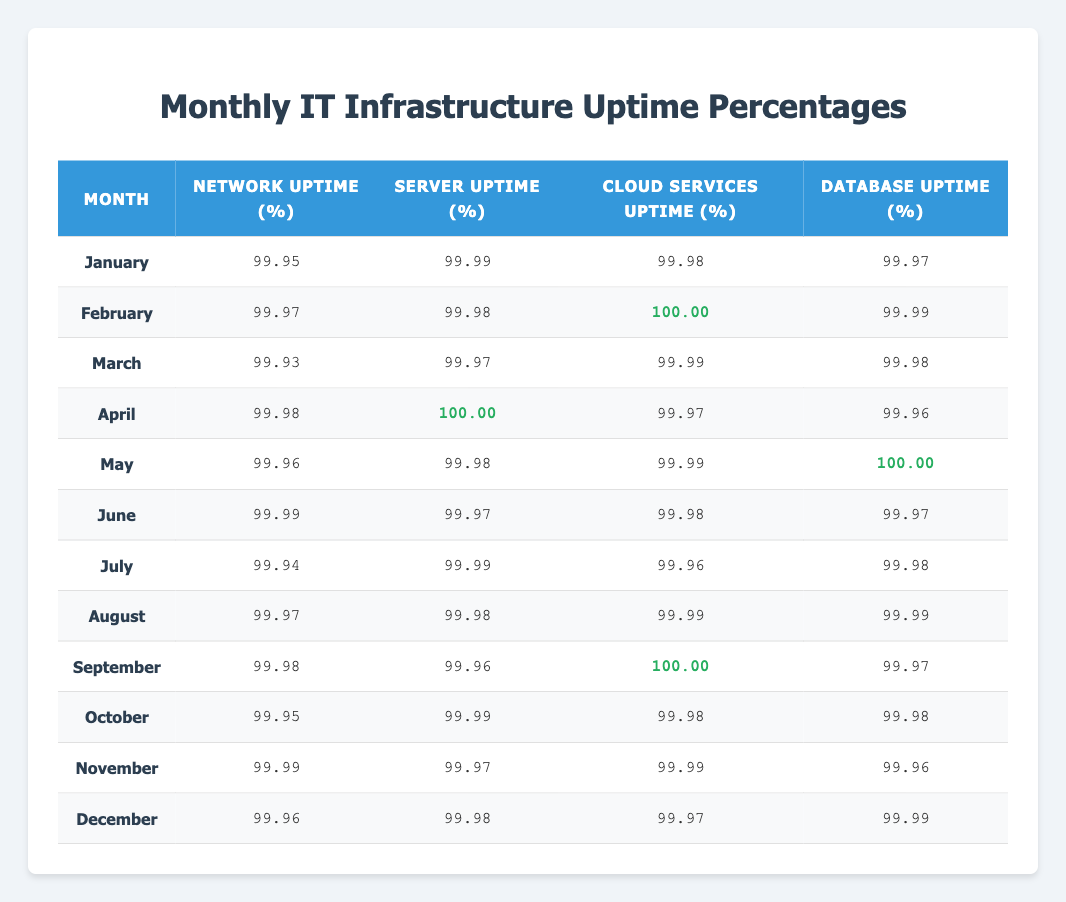What was the network uptime percentage in February? In the row for February, the corresponding value under the Network Uptime column is 99.97.
Answer: 99.97 Which month had the highest server uptime percentage? After comparing all the entries in the Server Uptime column, February and April both have a value of 100.00, which is the highest.
Answer: February and April What is the average cloud services uptime percentage for the year? To find the average, sum all the cloud services uptime percentages: (99.98 + 100.00 + 99.99 + 99.97 + 99.99 + 99.98 + 99.96 + 99.99 + 100.00 + 99.98 + 99.99 + 99.97) = 1199.88. Then divide by 12 (number of months): 1199.88 / 12 = 99.99.
Answer: 99.99 Did any month achieve 100% uptime for database services? Checking the Database Uptime column, February and May both show a value of 100.00. Therefore, the answer is true.
Answer: Yes Which month had the lowest network uptime percentage? The lowest value in the Network Uptime column is 99.93, which corresponds to the month of March.
Answer: March What is the difference between the highest and lowest database uptime percentages? The highest value in the Database Uptime column is 100.00 (in May), and the lowest is 99.96 (in April). Therefore, the difference is 100.00 - 99.96 = 0.04.
Answer: 0.04 Is the average server uptime percentage for the second half of the year above 99%? The server uptime percentages from July to December are: (99.99, 99.98, 99.96, 99.99, 99.97, 99.98) which sum up to 599.97. Dividing by 6 (the number of months) gives an average of 99.995, which is above 99%.
Answer: Yes How many months had cloud services uptime below 99.98%? Looking at the Cloud Services Uptime column, January (99.98), March (99.99), May (99.99), July (99.96), and November (99.97) have values below 99.98%. This totals to 1 month: July.
Answer: 1 month 